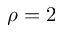<formula> <loc_0><loc_0><loc_500><loc_500>\rho = 2</formula> 